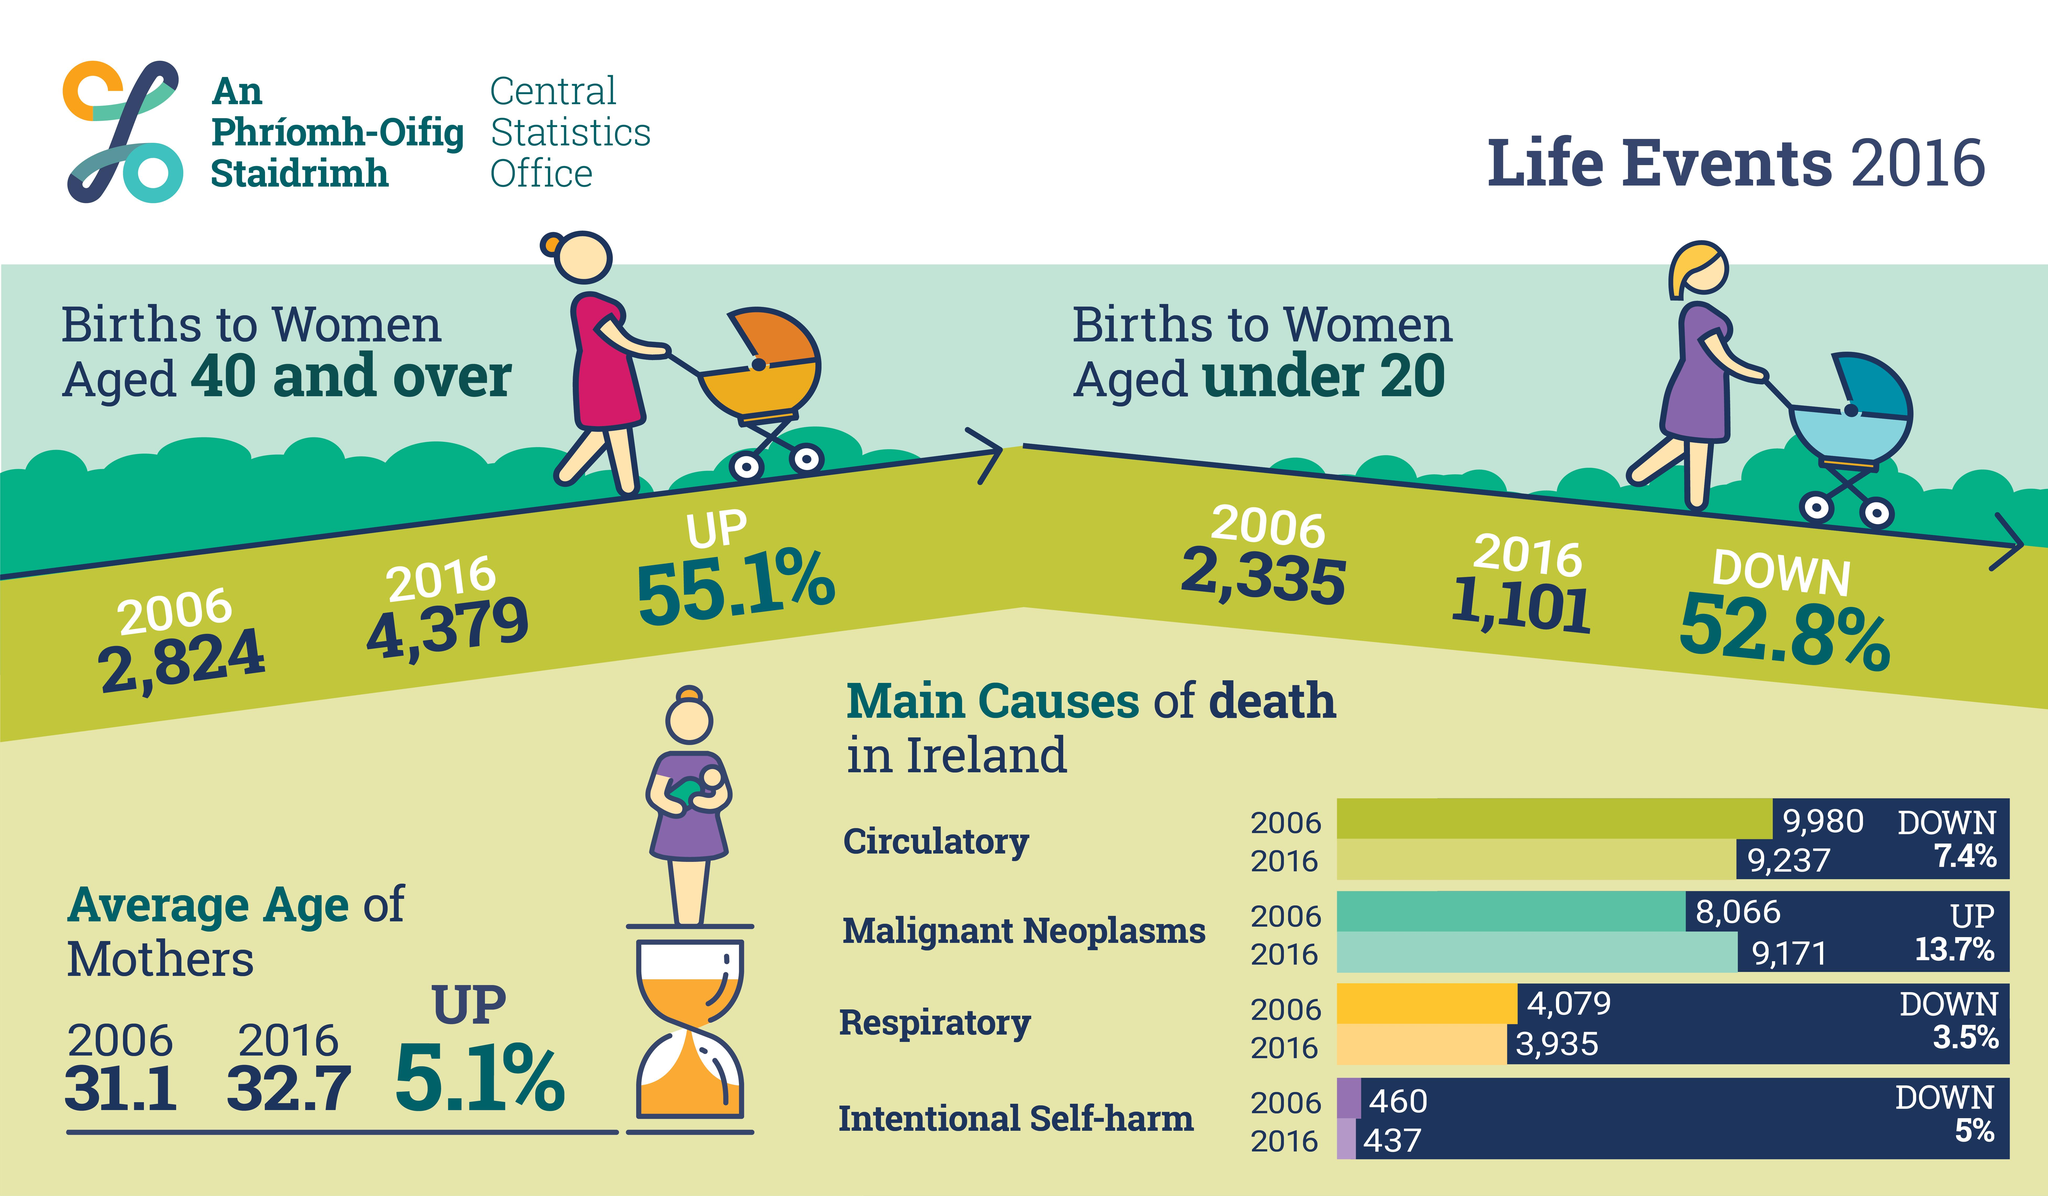Point out several critical features in this image. In 2016, women aged 40 and over had the highest birth rate among the age groups surveyed. According to data from 2016, circulatory diseases have shown a significant decrease in terms of percentage. The highest birth rate among women was observed in the age group under 20 in the year 2006. Malignant Neoplasms have become the leading cause of death in Ireland in 2016. During the period of 2006-2016, the average age of mothers has increased. 